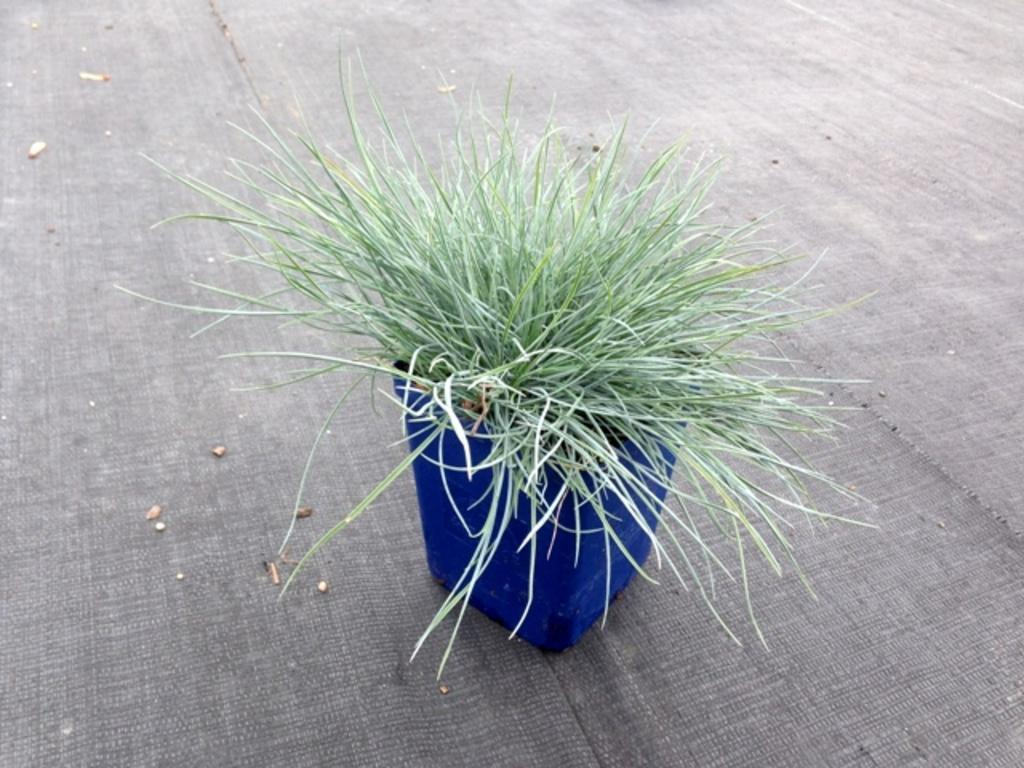What is present in the image? There is a plant in the image. What can be observed about the plant's container? The plant is in a blue-colored pot. What else can be seen on the surface in the image? There are objects on the surface in the image. What type of wax can be seen dripping from the plant in the image? There is no wax present in the image, and the plant is not dripping anything. 